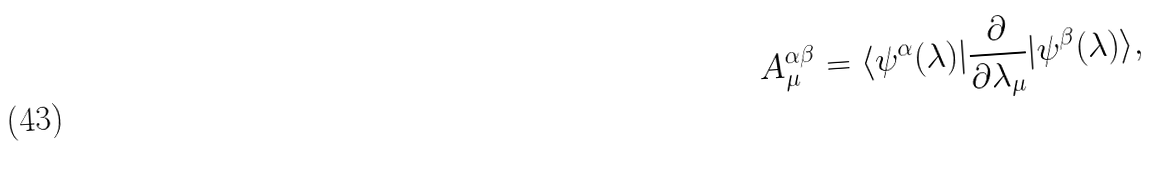<formula> <loc_0><loc_0><loc_500><loc_500>A _ { \mu } ^ { \alpha \beta } = \langle \psi ^ { \alpha } ( \lambda ) | \frac { \partial } { \partial \lambda _ { \mu } } | \psi ^ { \beta } ( \lambda ) \rangle ,</formula> 